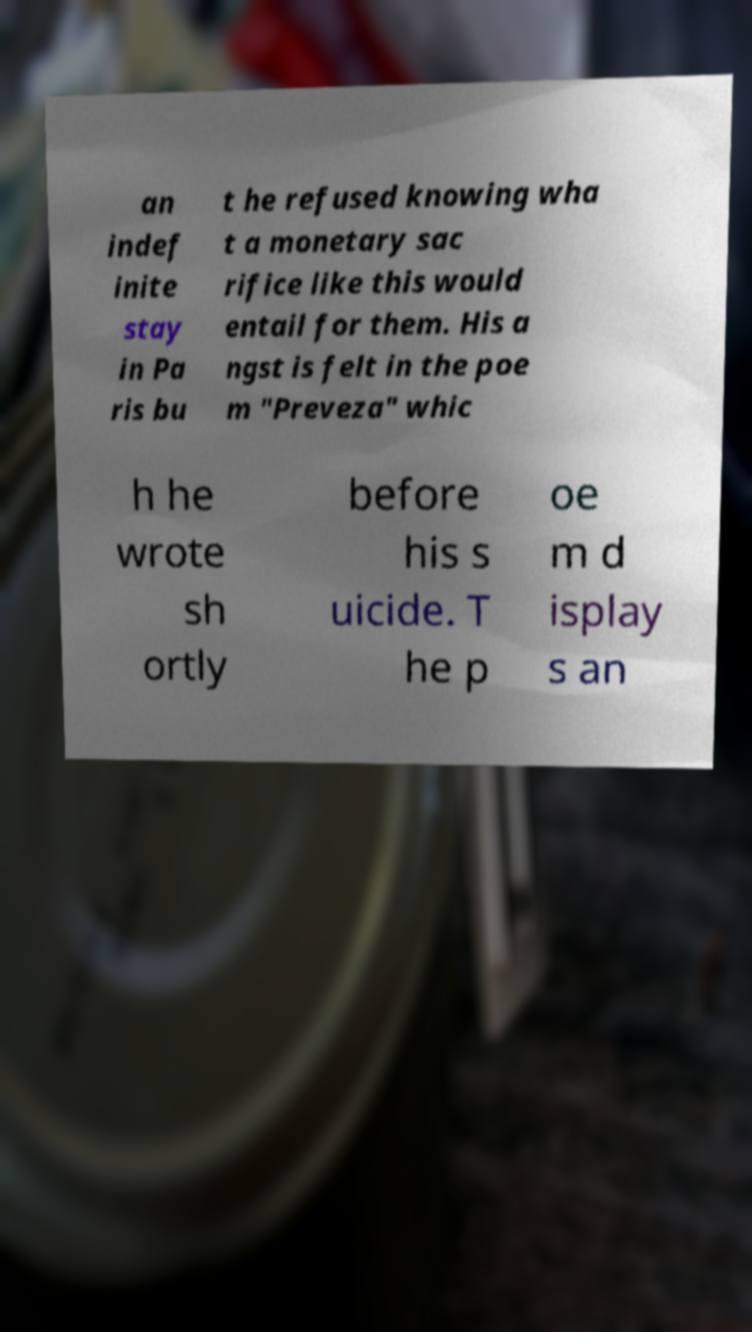Can you read and provide the text displayed in the image?This photo seems to have some interesting text. Can you extract and type it out for me? an indef inite stay in Pa ris bu t he refused knowing wha t a monetary sac rifice like this would entail for them. His a ngst is felt in the poe m "Preveza" whic h he wrote sh ortly before his s uicide. T he p oe m d isplay s an 